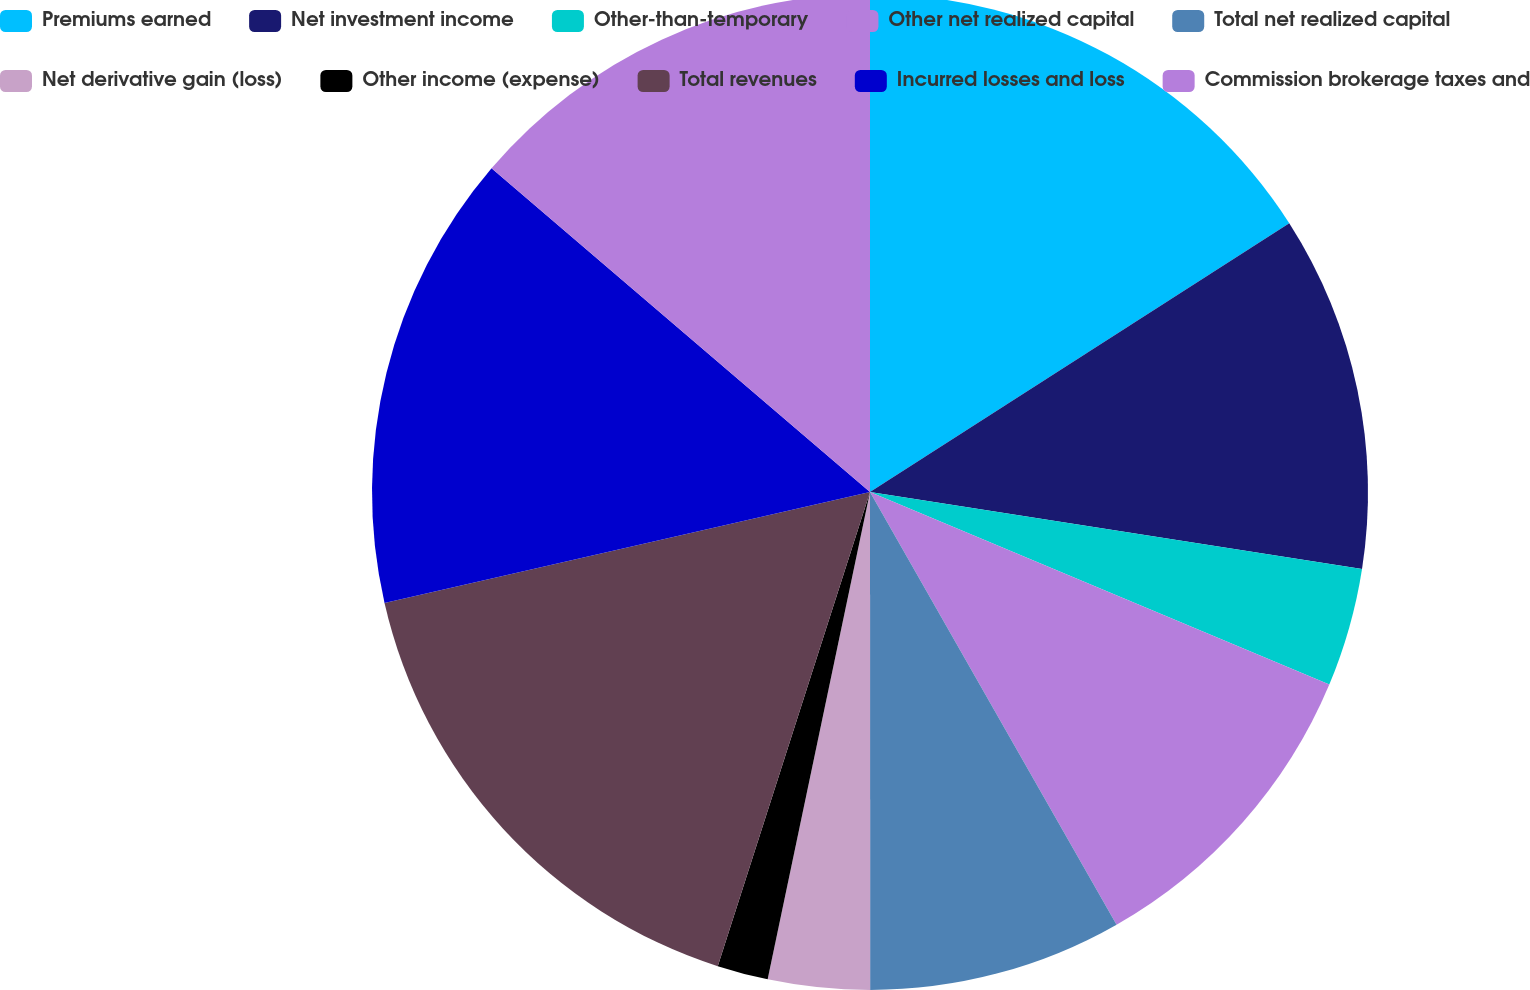Convert chart. <chart><loc_0><loc_0><loc_500><loc_500><pie_chart><fcel>Premiums earned<fcel>Net investment income<fcel>Other-than-temporary<fcel>Other net realized capital<fcel>Total net realized capital<fcel>Net derivative gain (loss)<fcel>Other income (expense)<fcel>Total revenues<fcel>Incurred losses and loss<fcel>Commission brokerage taxes and<nl><fcel>15.93%<fcel>11.54%<fcel>3.85%<fcel>10.44%<fcel>8.24%<fcel>3.3%<fcel>1.65%<fcel>16.48%<fcel>14.84%<fcel>13.74%<nl></chart> 